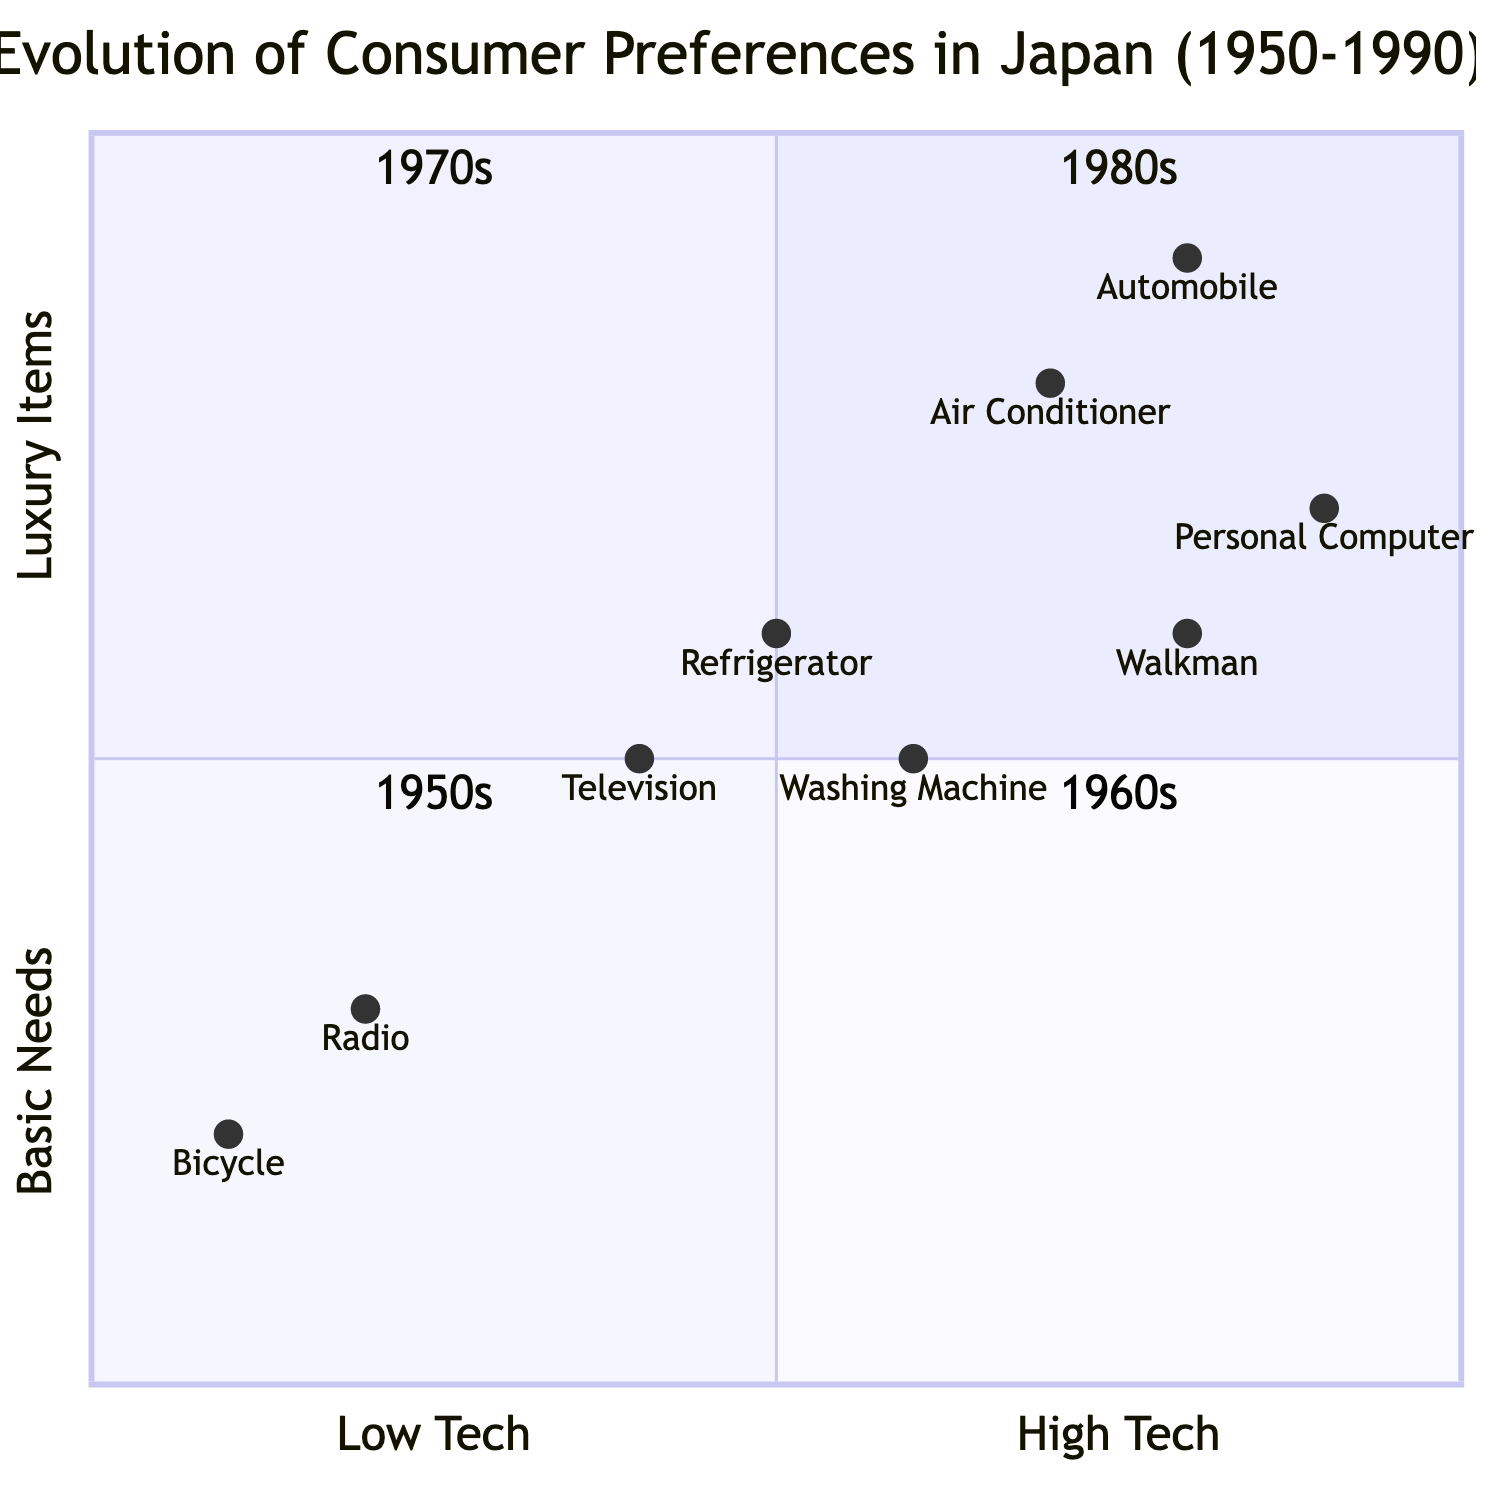What products are in the 1980s quadrant? The 1980s quadrant contains the products "Personal Computer" and "Portable Music Player (Walkman)" as listed under the elements of that quadrant.
Answer: Personal Computer, Portable Music Player (Walkman) Which decade features "Air Conditioner" as a product? The "Air Conditioner" is listed under the 1970s quadrant, which highlights its emergence as a consumer product during that decade.
Answer: 1970s How many products are listed for the 1960s? In the 1960s quadrant, there are three products: "Television," "Refrigerator," and "Washing Machine," making the total count three.
Answer: 3 Which quadrant has "Bicycle" and "Radio" as products? The products "Bicycle" and "Radio" are both listed in the 1950s quadrant, indicating the consumer preferences of that time.
Answer: 1950s What trend is associated with the 1980s quadrant? The trend associated with the 1980s quadrant is the "Digital revolution," which marks a significant change in consumer preferences during that decade.
Answer: Digital revolution Is "Television" considered a luxury item in the 1960s? In the 1960s quadrant, the position of "Television" is at [0.4, 0.5], indicating it falls between basic needs and luxury items, yet is closer to basic needs than luxury.
Answer: No Which product in the 1970s has the highest tech rating? Among the products listed in the 1970s quadrant, the "Automobile" has the highest tech rating at [0.8, 0.9], making it the most technologically advanced product of that decade.
Answer: Automobile What are the economy characteristics mentioned for the 1950s? The economy characteristics for the 1950s quadrant are "Rebuilding economy" and "Government interventions," reflecting the economic environment of that time.
Answer: Rebuilding economy, Government interventions Which quadrant represents the trend of "Brand consciousness"? The trend of "Brand consciousness" is represented in the 1980s quadrant, showcasing its relevance to consumers during that decade.
Answer: 1980s 